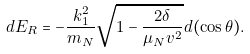<formula> <loc_0><loc_0><loc_500><loc_500>d E _ { R } = - \frac { k _ { 1 } ^ { 2 } } { m _ { N } } \sqrt { 1 - \frac { 2 \delta } { \mu _ { N } v ^ { 2 } } } d ( \cos \theta ) .</formula> 